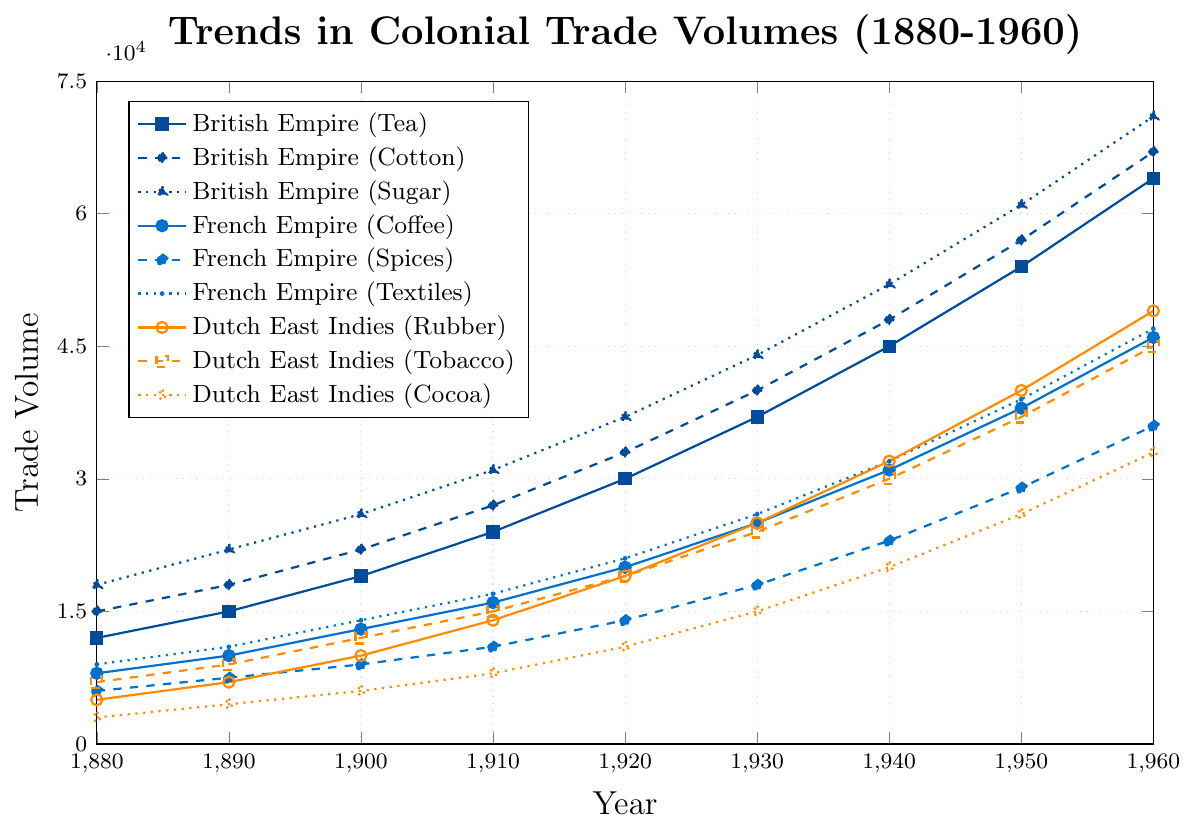Which commodity from the British Empire showed the highest trade volume in 1960? Locate the lines representing British Empire commodities (Tea, Cotton, Sugar) in 1960. Identify the highest point. Sugar has the highest trade volume.
Answer: Sugar What was the trade volume of Dutch East Indies (Tobacco) in 1920? Find the line for Dutch East Indies (Tobacco) and read the value at 1920.
Answer: 19000 How does the trade volume of French Empire (Spices) in 1940 compare to that of Dutch East Indies (Rubber) in the same year? Locate both data points on their respective lines and compare the values. French Empire (Spices) has a volume of 23000, while Dutch East Indies (Rubber) has 32000.
Answer: Dutch East Indies (Rubber) > French Empire (Spices) What is the approximate average trade volume for British Empire (Cotton) from 1880 to 1960? Sum the trade volumes of British Empire (Cotton) for each decade and divide by the number of data points: (15000 + 18000 + 22000 + 27000 + 33000 + 40000 + 48000 + 57000 + 67000) / 9
Answer: 36333 Between 1880 and 1900, which commodity from the French Empire showed the least change in trade volume? Calculate the change between 1900 and 1880 for each French Empire commodity: 
- Coffee: 13000 - 8000 = 5000
- Spices: 9000 - 6000 = 3000
- Textiles: 14000 - 9000 = 5000
Spices show the least change.
Answer: Spices By how much did the trade volume of British Empire (Sugar) increase from 1880 to 1960? Subtract the trade volume in 1880 from the trade volume in 1960: 71000 - 18000 = 53000
Answer: 53000 What color represents the Dutch East Indies (Cocoa) trade volume trend? Identify the color assigned to the Dutch East Indies (Cocoa) line in the plot.
Answer: Orange Which French Empire commodity saw the greatest increase in trade volume from 1930 to 1940? Calculate the increase for each French Empire commodity between 1930 and 1940:
- Coffee: 31000 - 25000 = 6000
- Spices: 23000 - 18000 = 5000
- Textiles: 32000 - 26000 = 6000
Both Coffee and Textiles show the same maximum increase.
Answer: Coffee and Textiles Which year shows an equal trade volume for both French Empire (Coffee) and Dutch East Indies (Rubber)? Find the year where the values for French Empire (Coffee) and Dutch East Indies (Rubber) lines intersect. They intersect at 1930.
Answer: 1930 How much was the British Empire (Tea) trade volume in 1950 relative to 1940? To find the relative increase, subtract the 1940 value from the 1950 value and divide by the 1940 value: (54000 - 45000) / 45000 = 0.2 or 20%
Answer: 20% 